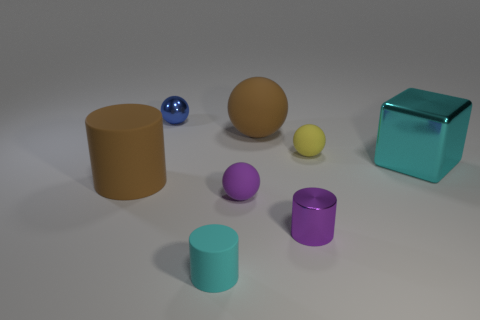Add 1 yellow things. How many objects exist? 9 Subtract all cubes. How many objects are left? 7 Add 5 large brown cylinders. How many large brown cylinders exist? 6 Subtract 0 yellow cubes. How many objects are left? 8 Subtract all tiny red things. Subtract all brown things. How many objects are left? 6 Add 7 tiny blue metallic spheres. How many tiny blue metallic spheres are left? 8 